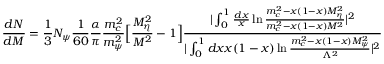<formula> <loc_0><loc_0><loc_500><loc_500>\frac { d N } { d M } = \frac { 1 } { 3 } N _ { \psi } \frac { 1 } { 6 0 } \frac { \alpha } { \pi } \frac { m _ { c } ^ { 2 } } { m _ { \psi } ^ { 2 } } \left [ \frac { M _ { \eta } ^ { 2 } } { M ^ { 2 } } - 1 \right ] \frac { | \int _ { 0 } ^ { 1 } { \frac { d x } { x } } \ln \frac { m _ { c } ^ { 2 } - x ( 1 - x ) M _ { \eta } ^ { 2 } } { m _ { c } ^ { 2 } - x ( 1 - x ) M ^ { 2 } } | ^ { 2 } } { | \int _ { 0 } ^ { 1 } d x x ( 1 - x ) \ln \frac { m _ { c } ^ { 2 } - x ( 1 - x ) M _ { \psi } ^ { 2 } } { \Lambda ^ { 2 } } | ^ { 2 } }</formula> 